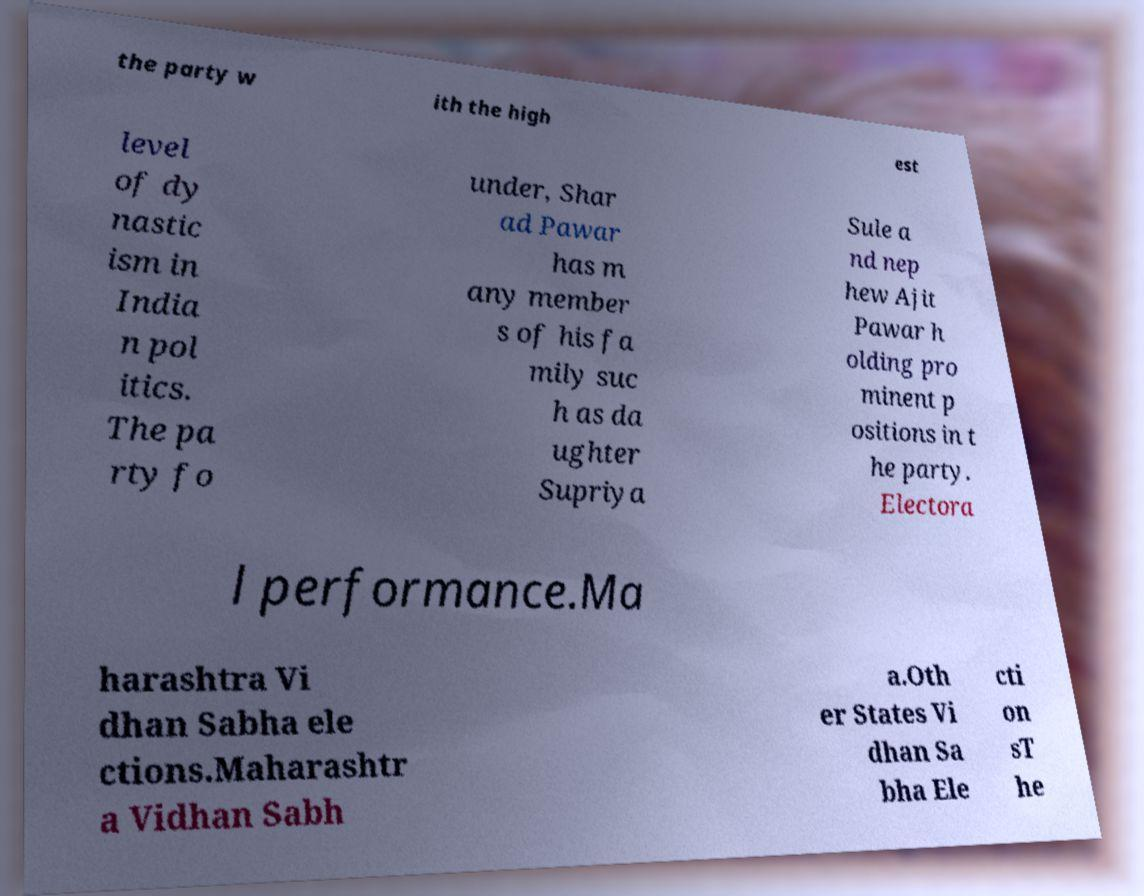I need the written content from this picture converted into text. Can you do that? the party w ith the high est level of dy nastic ism in India n pol itics. The pa rty fo under, Shar ad Pawar has m any member s of his fa mily suc h as da ughter Supriya Sule a nd nep hew Ajit Pawar h olding pro minent p ositions in t he party. Electora l performance.Ma harashtra Vi dhan Sabha ele ctions.Maharashtr a Vidhan Sabh a.Oth er States Vi dhan Sa bha Ele cti on sT he 